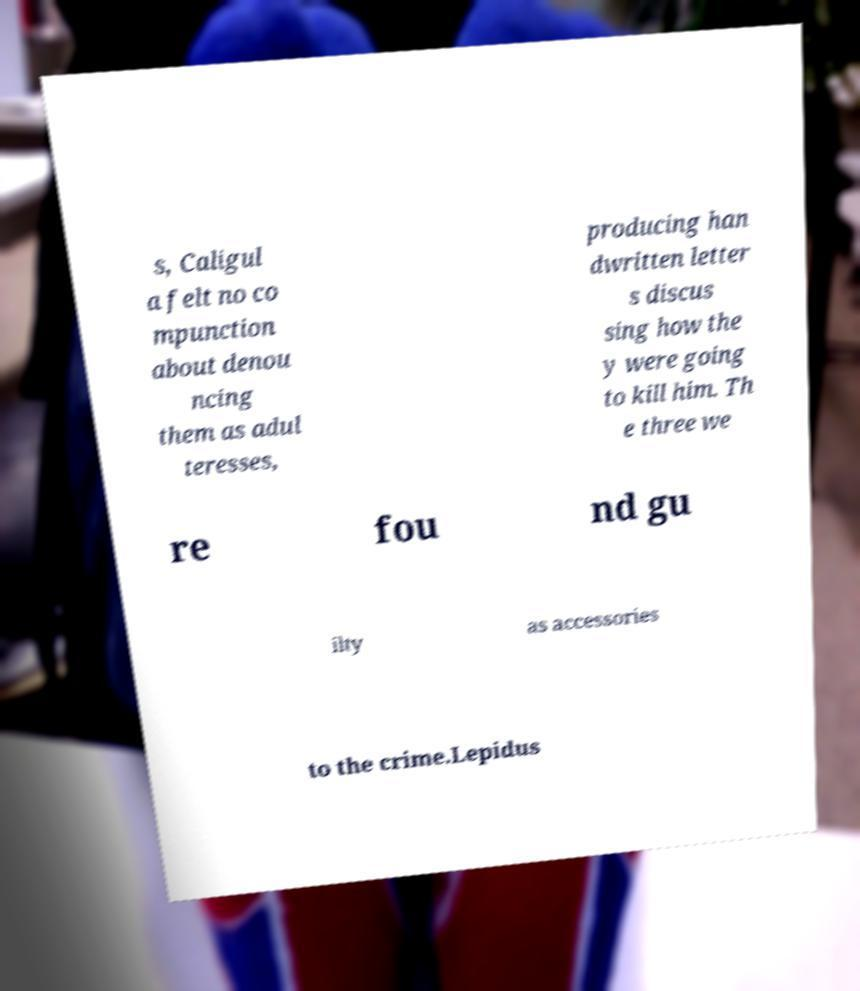Please identify and transcribe the text found in this image. s, Caligul a felt no co mpunction about denou ncing them as adul teresses, producing han dwritten letter s discus sing how the y were going to kill him. Th e three we re fou nd gu ilty as accessories to the crime.Lepidus 